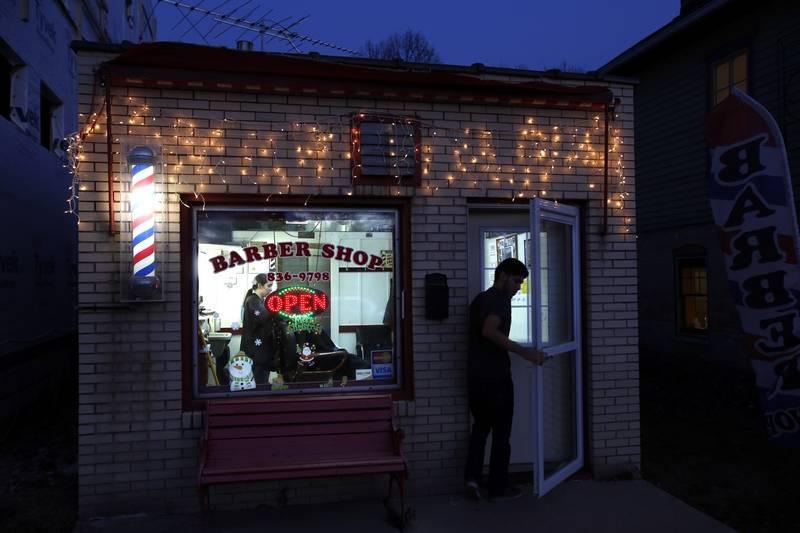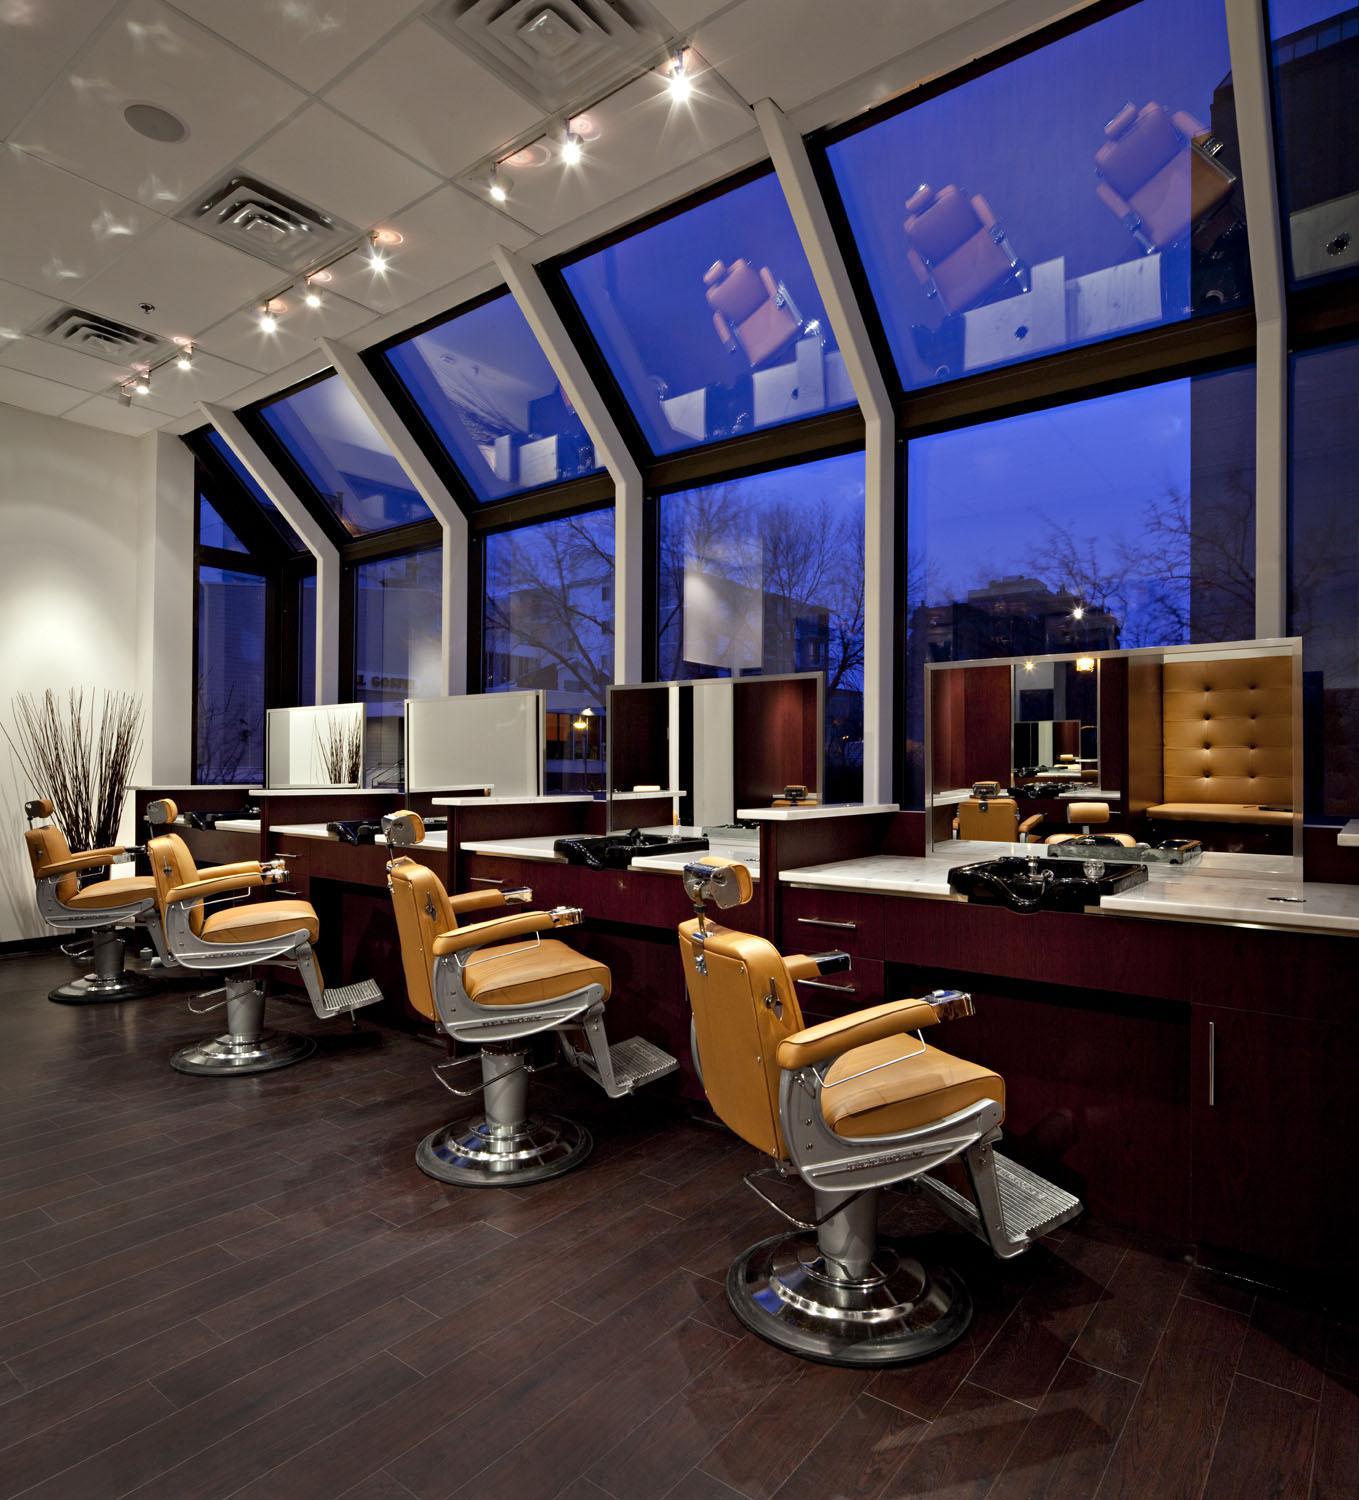The first image is the image on the left, the second image is the image on the right. Given the left and right images, does the statement "There is a barber pole in one of the iamges." hold true? Answer yes or no. Yes. The first image is the image on the left, the second image is the image on the right. Given the left and right images, does the statement "One image is the interior of a barber shop and one image is the exterior of a barber shop" hold true? Answer yes or no. Yes. 